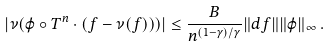<formula> <loc_0><loc_0><loc_500><loc_500>| \nu ( \varphi \circ T ^ { n } \cdot ( f - \nu ( f ) ) ) | \leq \frac { B } { n ^ { ( 1 - \gamma ) / \gamma } } \| d f \| \| \varphi \| _ { \infty } \, .</formula> 